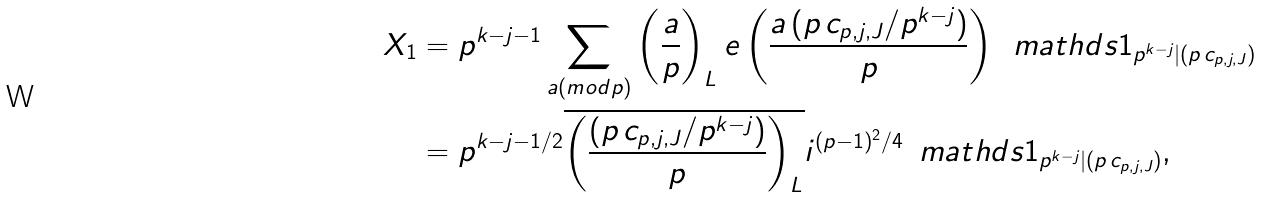Convert formula to latex. <formula><loc_0><loc_0><loc_500><loc_500>X _ { 1 } & = p ^ { k - j - 1 } \sum _ { a ( m o d p ) } \left ( \frac { a } { p } \right ) _ { L } e \left ( \frac { a \, ( p \, c _ { p , j , J } / p ^ { k - j } ) } { p } \right ) \, \ m a t h d s { 1 } _ { p ^ { k - j } | ( p \, c _ { p , j , J } ) } \\ & = p ^ { k - j - 1 / 2 } \overline { \left ( \frac { ( p \, c _ { p , j , J } / p ^ { k - j } ) } { p } \right ) _ { L } } i ^ { ( p - 1 ) ^ { 2 } / 4 } \, \ m a t h d s { 1 } _ { p ^ { k - j } | ( p \, c _ { p , j , J } ) } ,</formula> 